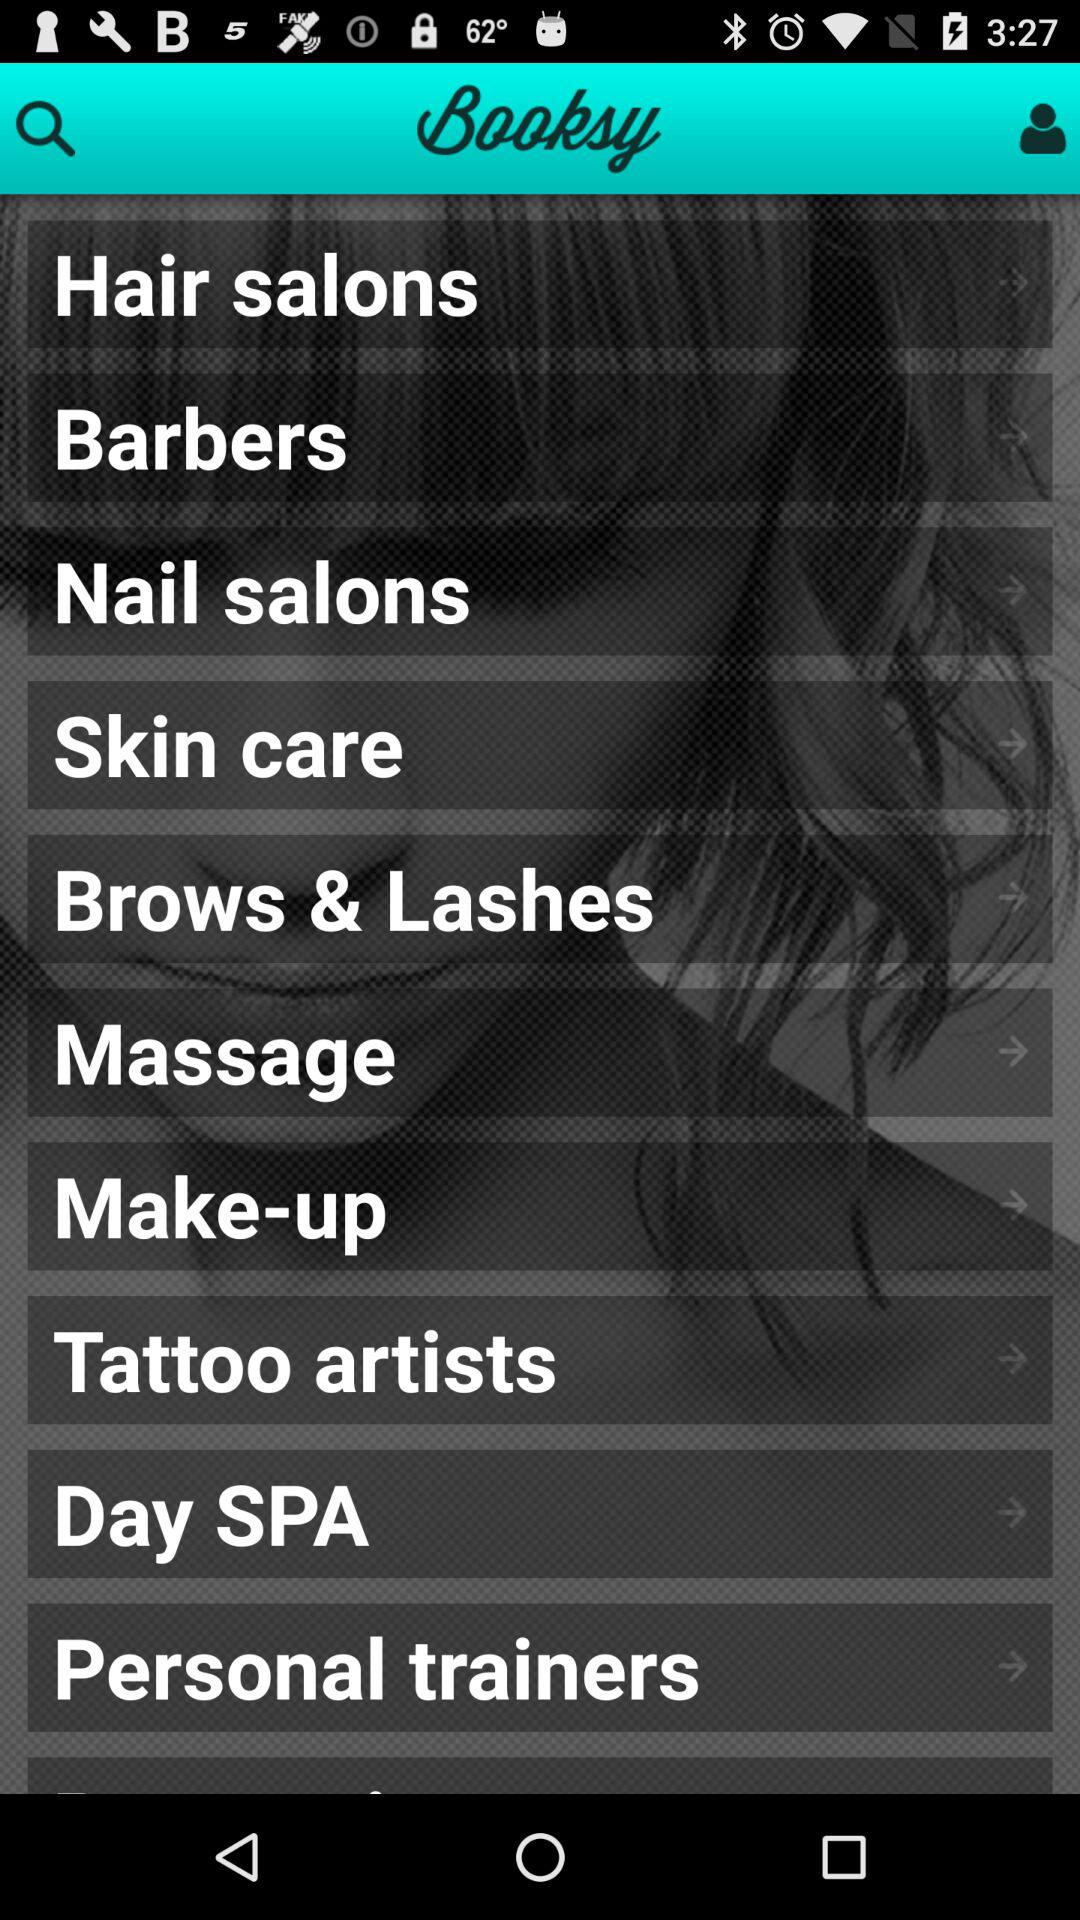What is the name of the application? The name of the application is "Booksy". 